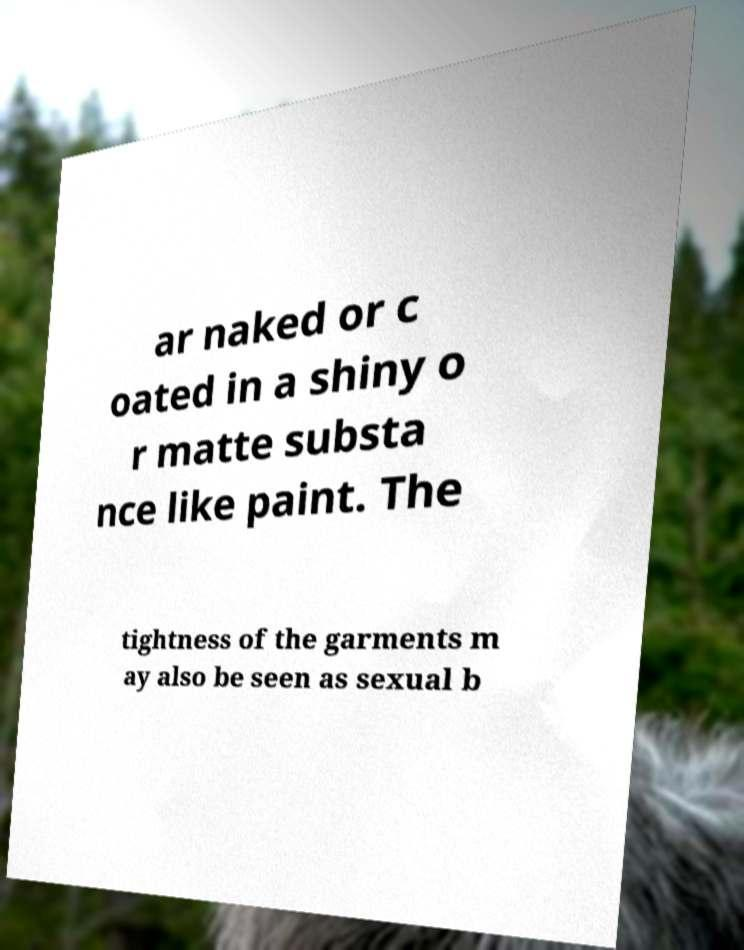Please identify and transcribe the text found in this image. ar naked or c oated in a shiny o r matte substa nce like paint. The tightness of the garments m ay also be seen as sexual b 